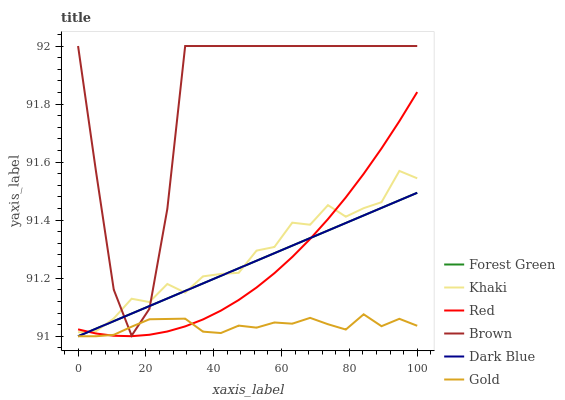Does Gold have the minimum area under the curve?
Answer yes or no. Yes. Does Brown have the maximum area under the curve?
Answer yes or no. Yes. Does Khaki have the minimum area under the curve?
Answer yes or no. No. Does Khaki have the maximum area under the curve?
Answer yes or no. No. Is Forest Green the smoothest?
Answer yes or no. Yes. Is Brown the roughest?
Answer yes or no. Yes. Is Khaki the smoothest?
Answer yes or no. No. Is Khaki the roughest?
Answer yes or no. No. Does Gold have the lowest value?
Answer yes or no. Yes. Does Khaki have the lowest value?
Answer yes or no. No. Does Brown have the highest value?
Answer yes or no. Yes. Does Khaki have the highest value?
Answer yes or no. No. Is Gold less than Khaki?
Answer yes or no. Yes. Is Brown greater than Red?
Answer yes or no. Yes. Does Khaki intersect Forest Green?
Answer yes or no. Yes. Is Khaki less than Forest Green?
Answer yes or no. No. Is Khaki greater than Forest Green?
Answer yes or no. No. Does Gold intersect Khaki?
Answer yes or no. No. 